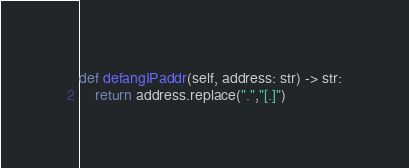<code> <loc_0><loc_0><loc_500><loc_500><_Python_>def defangIPaddr(self, address: str) -> str:
    return address.replace(".","[.]")</code> 